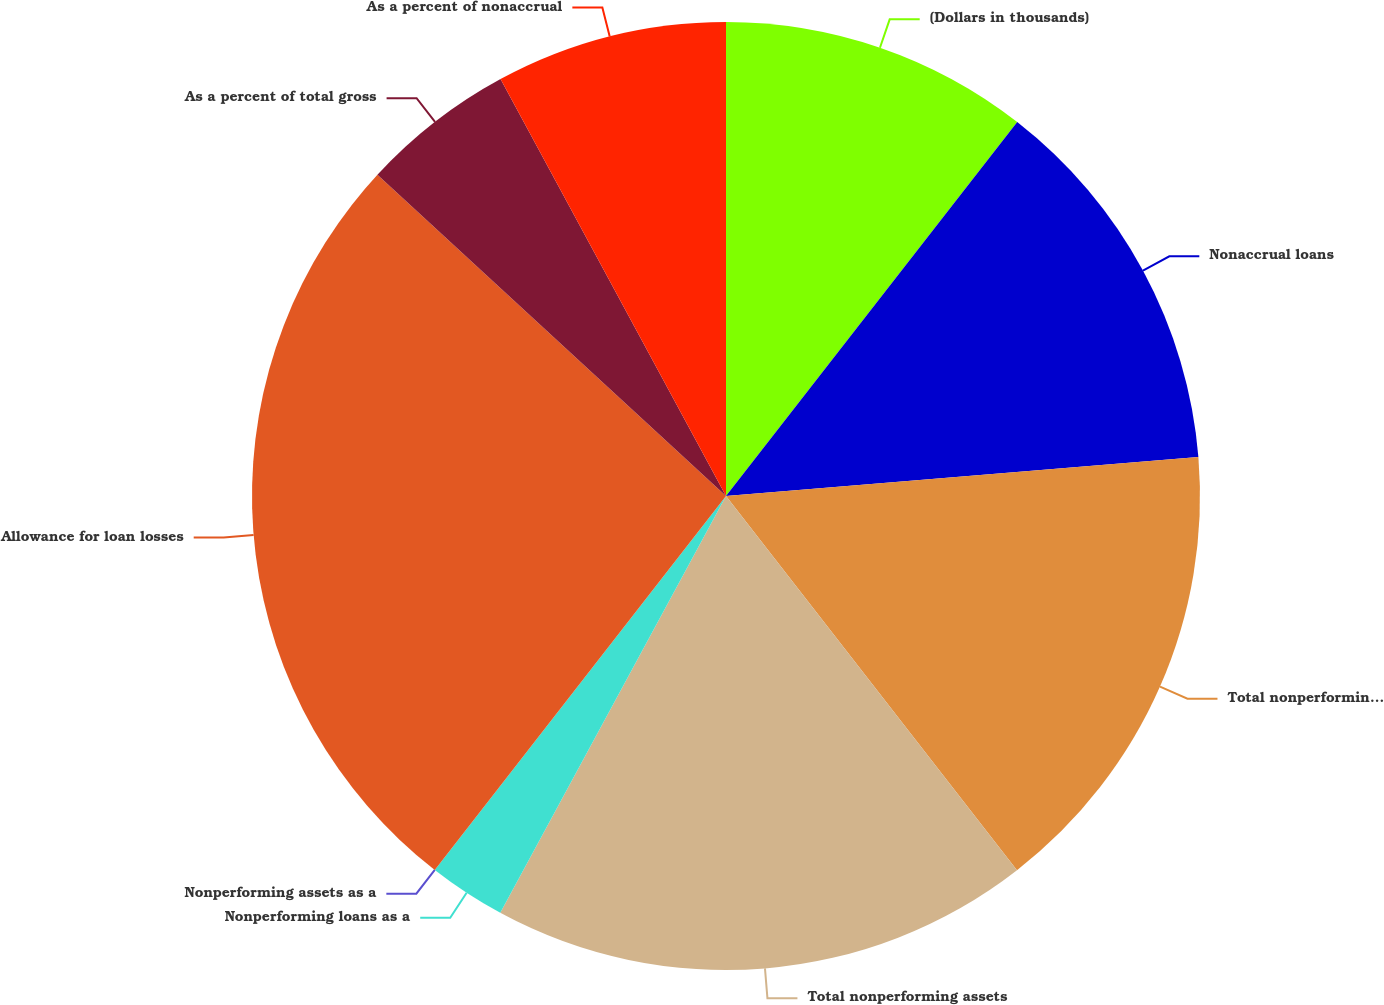<chart> <loc_0><loc_0><loc_500><loc_500><pie_chart><fcel>(Dollars in thousands)<fcel>Nonaccrual loans<fcel>Total nonperforming loans<fcel>Total nonperforming assets<fcel>Nonperforming loans as a<fcel>Nonperforming assets as a<fcel>Allowance for loan losses<fcel>As a percent of total gross<fcel>As a percent of nonaccrual<nl><fcel>10.53%<fcel>13.16%<fcel>15.79%<fcel>18.42%<fcel>2.63%<fcel>0.0%<fcel>26.32%<fcel>5.26%<fcel>7.89%<nl></chart> 